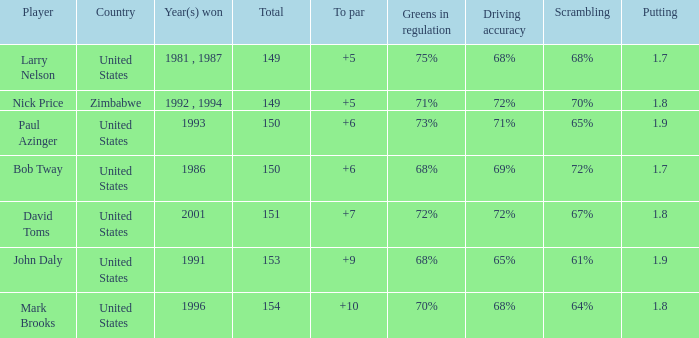What is Zimbabwe's total with a to par higher than 5? None. 